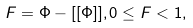Convert formula to latex. <formula><loc_0><loc_0><loc_500><loc_500>F = \Phi - [ [ \Phi ] ] , 0 \leq F < 1 ,</formula> 